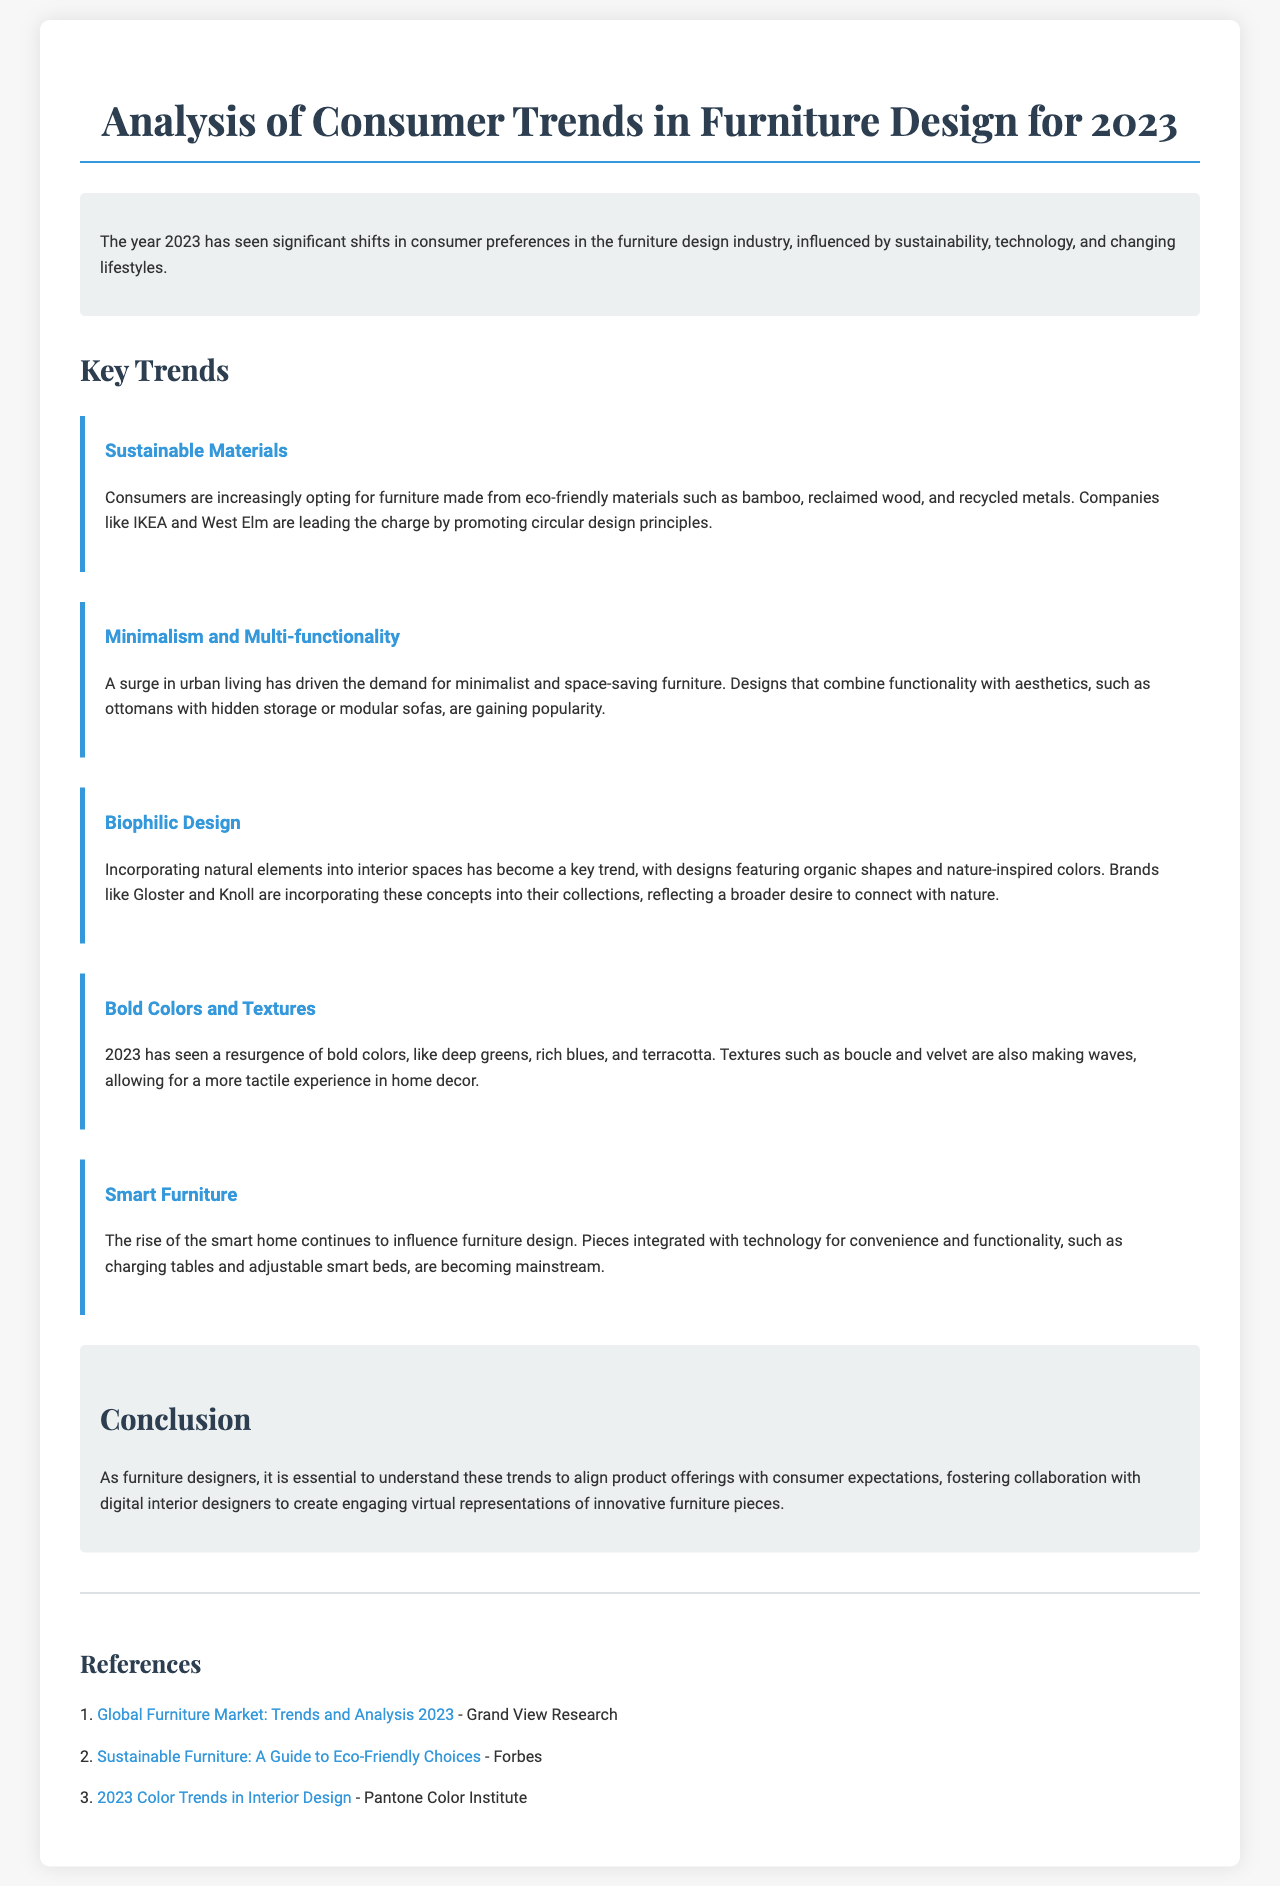What is the main focus of the report? The report discusses consumer preferences and trends in the furniture design industry for the year 2023.
Answer: Consumer trends in furniture design Which material is increasingly preferred by consumers? The document states that consumers are opting for eco-friendly materials like bamboo and reclaimed wood.
Answer: Eco-friendly materials What design style is gaining popularity due to urban living? According to the report, minimalist and space-saving furniture is becoming more requested due to urban living conditions.
Answer: Minimalism Name a brand that promotes circular design principles. The report mentions IKEA as a company leading the charge in promoting sustainable practices.
Answer: IKEA What color trend is highlighted in 2023? The document indicates that bold colors such as deep greens and rich blues are trending this year.
Answer: Bold colors What type of technology is influencing furniture design? The report talks about the rise of smart technology integrated into furniture, such as charging tables.
Answer: Smart technology Which natural design concept is mentioned in the report? Biophilic design is described as incorporating natural elements into interior spaces.
Answer: Biophilic design What is a key conclusion of the report? The conclusion emphasizes the importance for furniture designers to understand trends to align their products with consumer expectations.
Answer: Understanding trends Which interior design aspect features organic shapes? The report mentions that biophilic design includes elements that feature organic shapes.
Answer: Biophilic design 